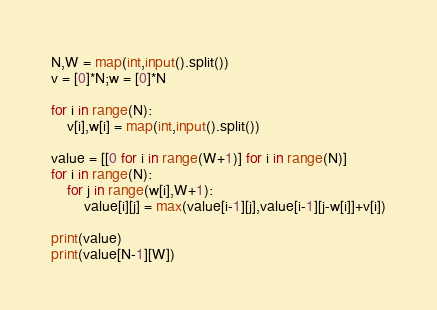Convert code to text. <code><loc_0><loc_0><loc_500><loc_500><_Python_>N,W = map(int,input().split())
v = [0]*N;w = [0]*N

for i in range(N):
    v[i],w[i] = map(int,input().split())

value = [[0 for i in range(W+1)] for i in range(N)]
for i in range(N):
    for j in range(w[i],W+1):
        value[i][j] = max(value[i-1][j],value[i-1][j-w[i]]+v[i])

print(value)
print(value[N-1][W])</code> 